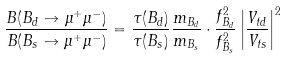Convert formula to latex. <formula><loc_0><loc_0><loc_500><loc_500>\frac { B ( B _ { d } \to \mu ^ { + } \mu ^ { - } ) } { B ( B _ { s } \to \mu ^ { + } \mu ^ { - } ) } = \frac { \tau ( B _ { d } ) } { \tau ( B _ { s } ) } \frac { m _ { B _ { d } } } { m _ { B _ { s } } } \cdot \frac { f _ { B _ { d } } ^ { 2 } } { f _ { B _ { s } } ^ { 2 } } \left | \frac { V _ { t d } } { V _ { t s } } \right | ^ { 2 }</formula> 